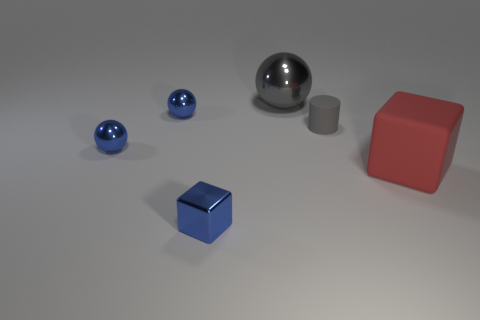Subtract all blue shiny balls. How many balls are left? 1 Subtract 1 balls. How many balls are left? 2 Add 2 tiny gray things. How many objects exist? 8 Subtract all blocks. How many objects are left? 4 Subtract 0 yellow blocks. How many objects are left? 6 Subtract all tiny blue metallic cylinders. Subtract all big gray metal balls. How many objects are left? 5 Add 5 gray shiny spheres. How many gray shiny spheres are left? 6 Add 5 large metal things. How many large metal things exist? 6 